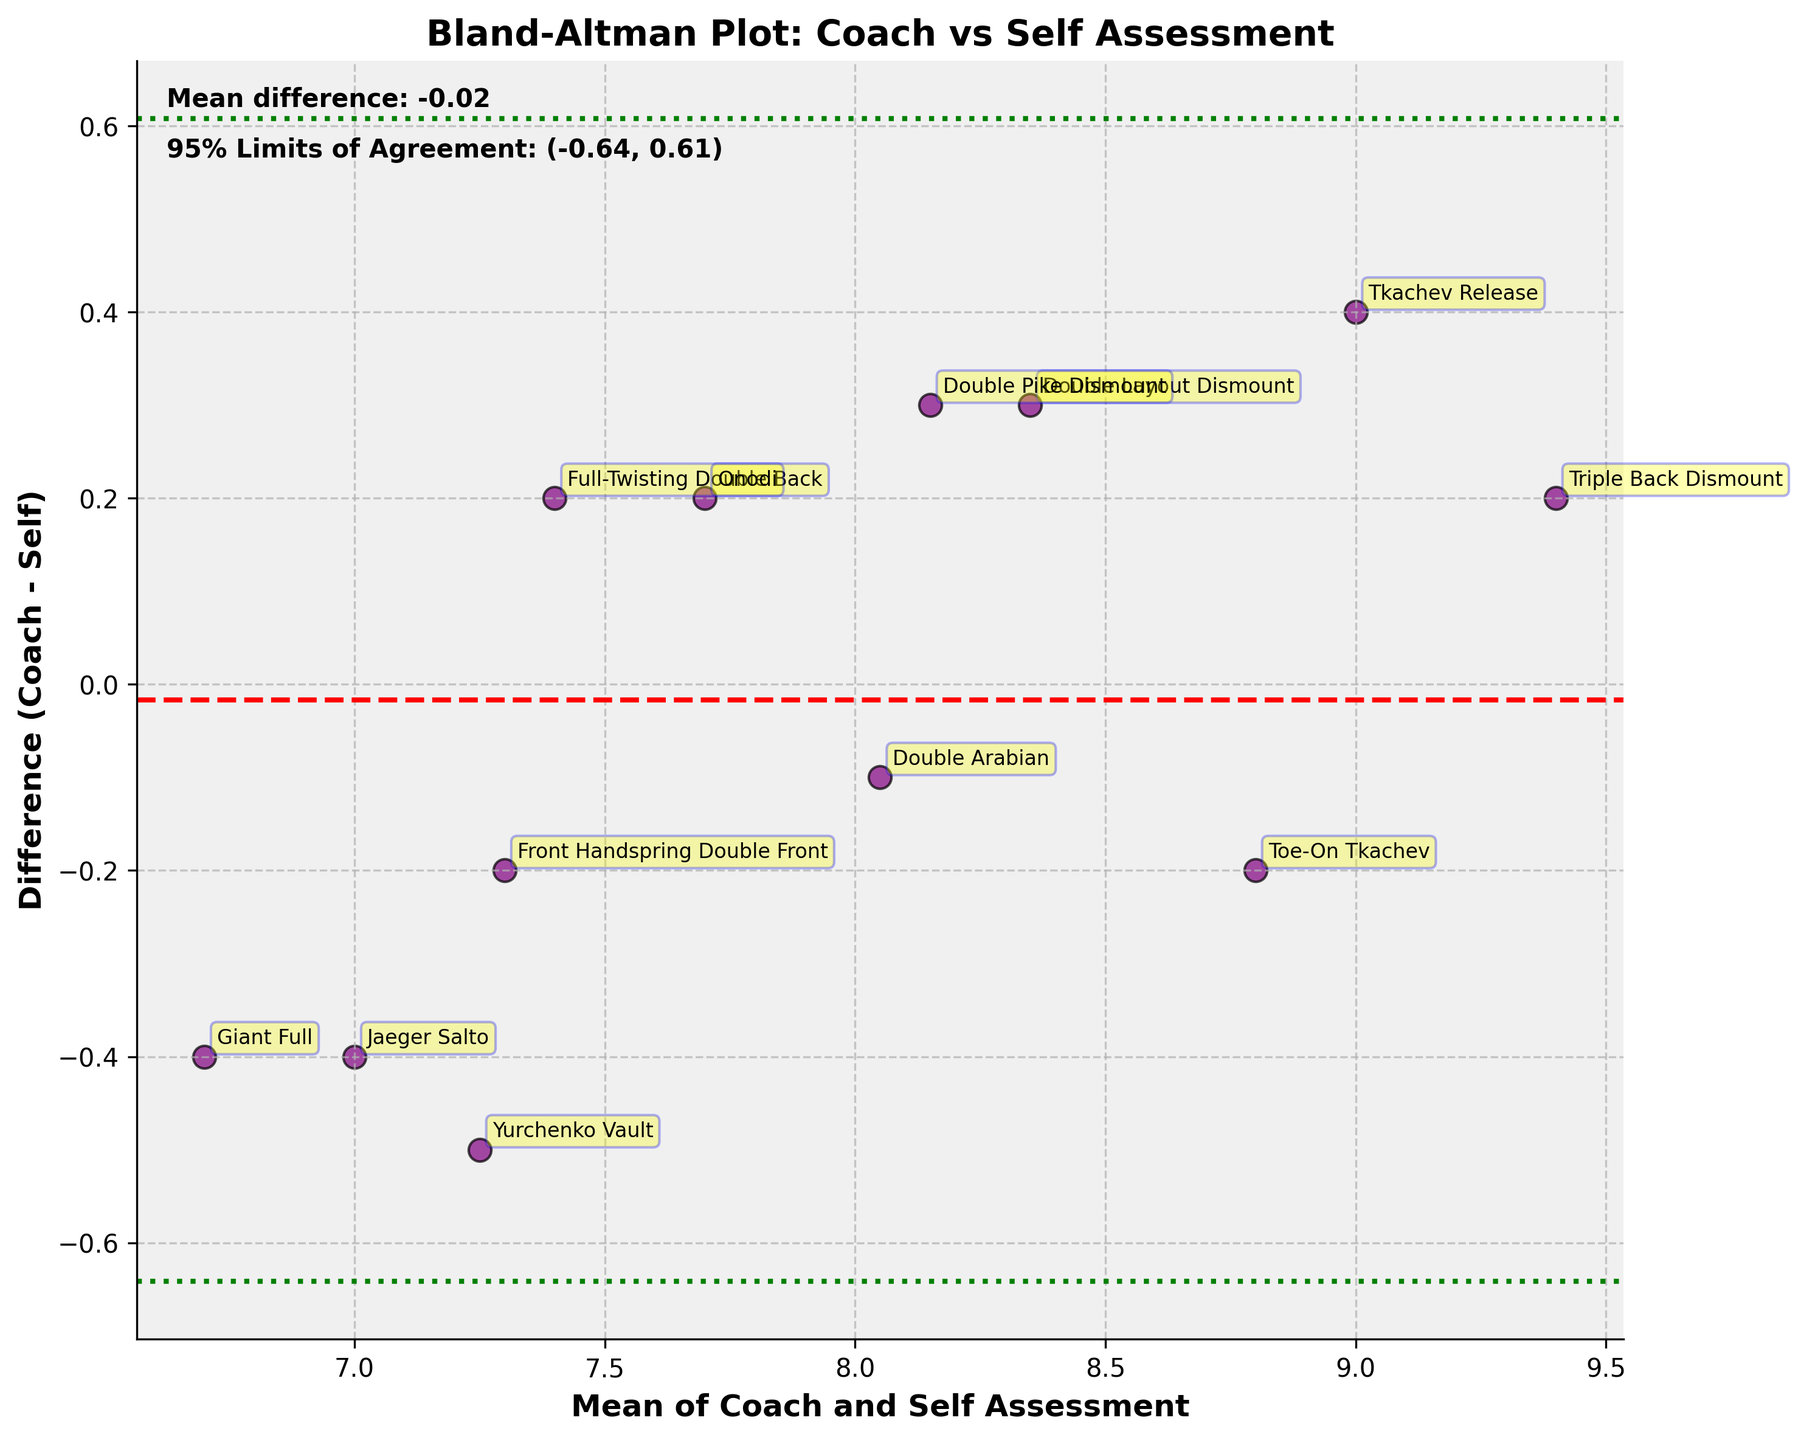What's the title of the plot? The title of the plot is found at the top of the figure.
Answer: Bland-Altman Plot: Coach vs Self Assessment What does the red dashed line represent in the plot? The red dashed line represents the mean difference between the coach's assessments and self-assessments.
Answer: Mean difference What are the green dotted lines in the figure? The green dotted lines denote the limits of agreement, which are calculated as the mean difference ± 1.96 times the standard deviation of the differences.
Answer: Limits of agreement How many data points are there in the plot? Count the number of data points (distinct markers) scattered on the plot.
Answer: 12 What skill has the largest discrepancy between coach and self-assessment? Look for the point that is furthest from the mean difference (red dashed line) and identify its label.
Answer: Tkachev Release What are the values of the 95% limits of agreement? The values of the 95% limits of agreement are typically shown as text in the figure.
Answer: (-0.66, 0.95) Which skill has the smallest difference between coach and self-assessment? Look for the data point closest to the mean difference line (red dashed line) and identify its label.
Answer: Double Arabian What is the mean difference between the coach's assessments and the self-assessments? The mean difference is displayed as a text annotation near the plot, typically next to the red dashed line.
Answer: 0.15 Is the majority of the differences within the limits of agreement? Check if the majority of data points fall between the green dashed lines.
Answer: Yes Which skills indicate the coach rated higher than the self-assessment? Identify the points where the difference (Coach - Self) is positive and locate the skill names.
Answer: Double Layout Dismount, Full-Twisting Double Back, Triple Back Dismount 